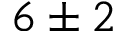<formula> <loc_0><loc_0><loc_500><loc_500>6 \pm 2</formula> 